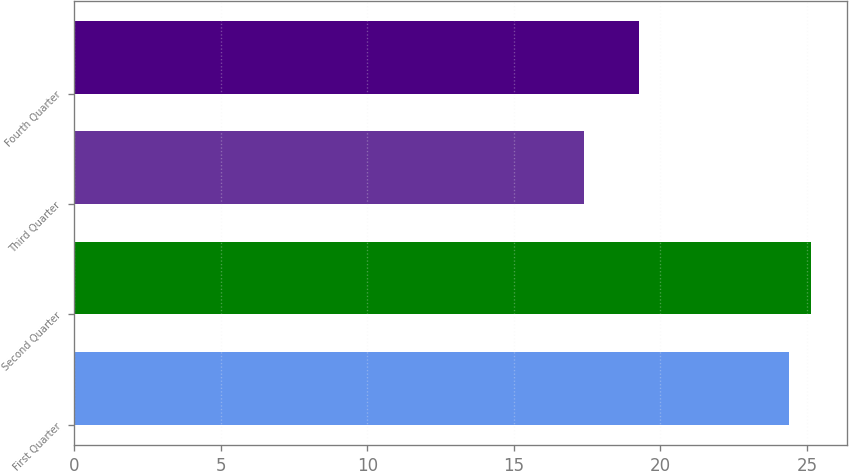<chart> <loc_0><loc_0><loc_500><loc_500><bar_chart><fcel>First Quarter<fcel>Second Quarter<fcel>Third Quarter<fcel>Fourth Quarter<nl><fcel>24.4<fcel>25.12<fcel>17.4<fcel>19.26<nl></chart> 